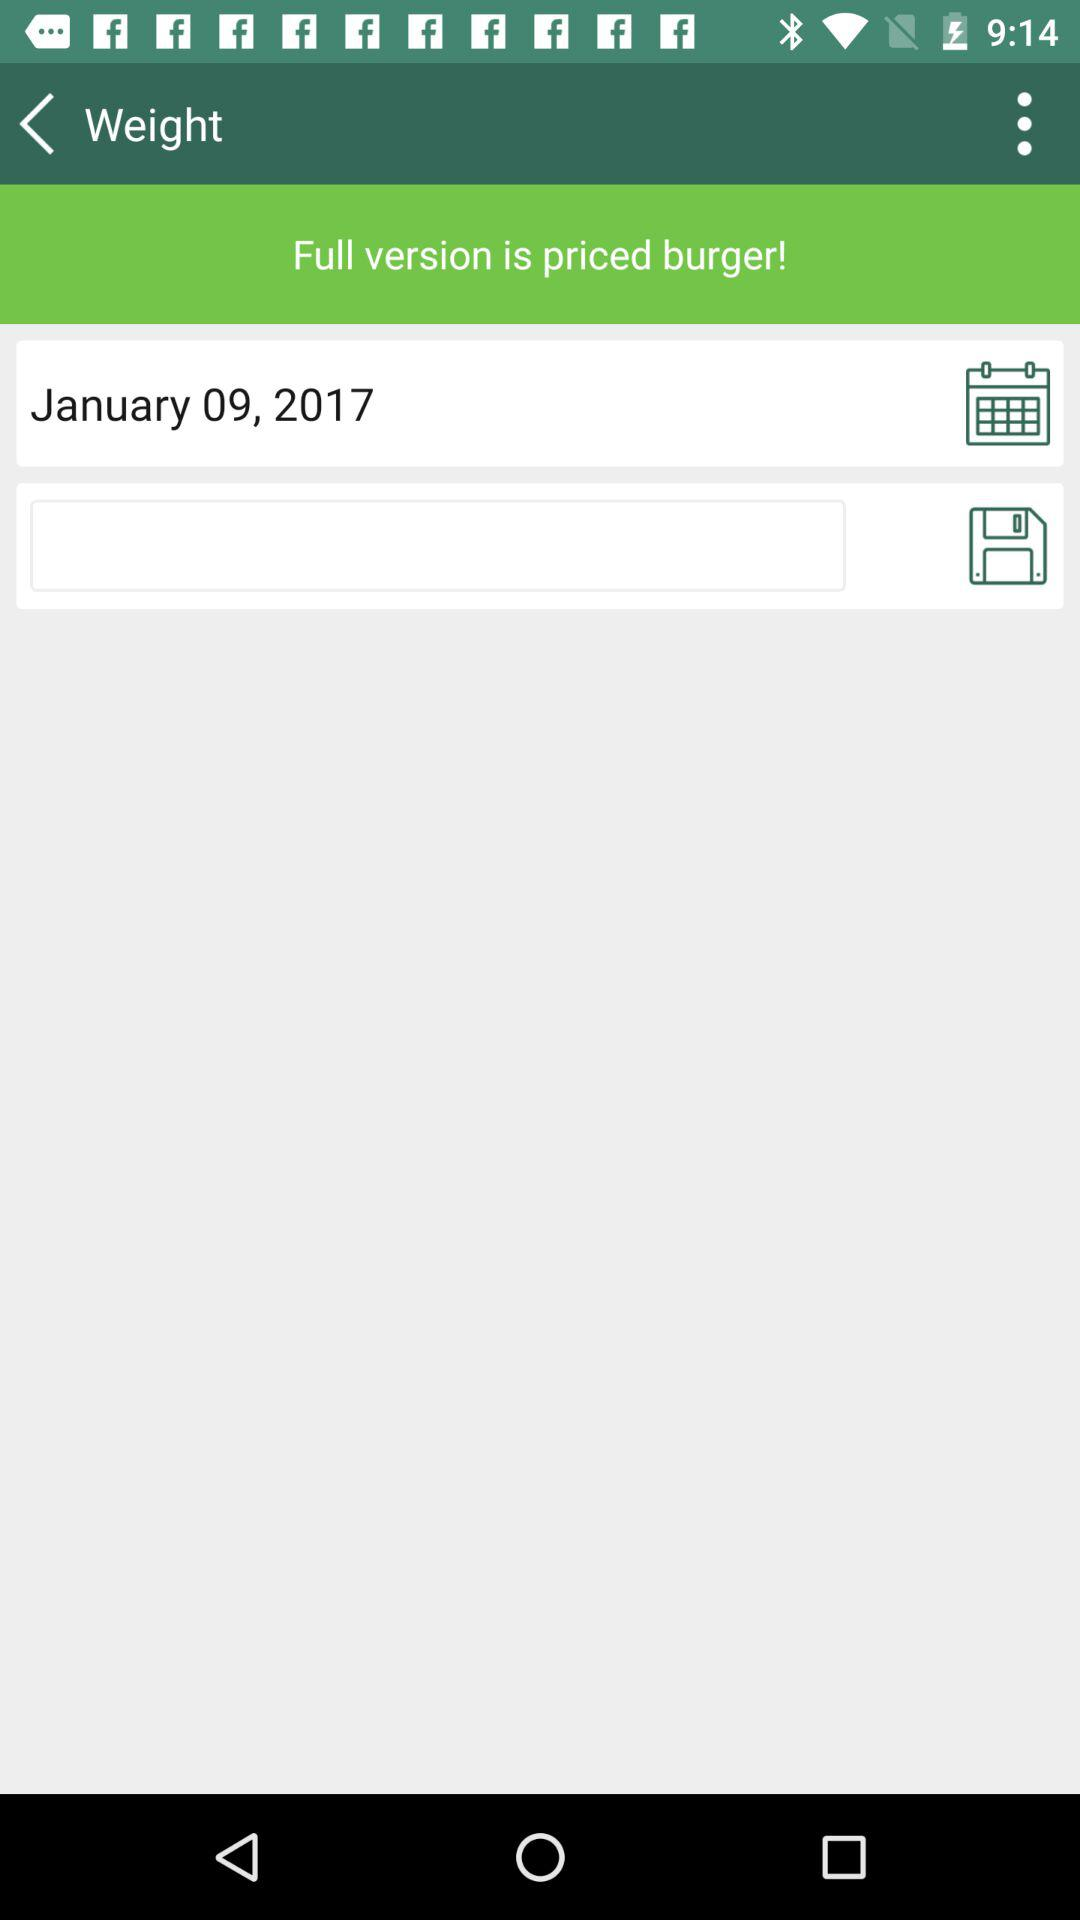What is the date? The date is January 9, 2017. 